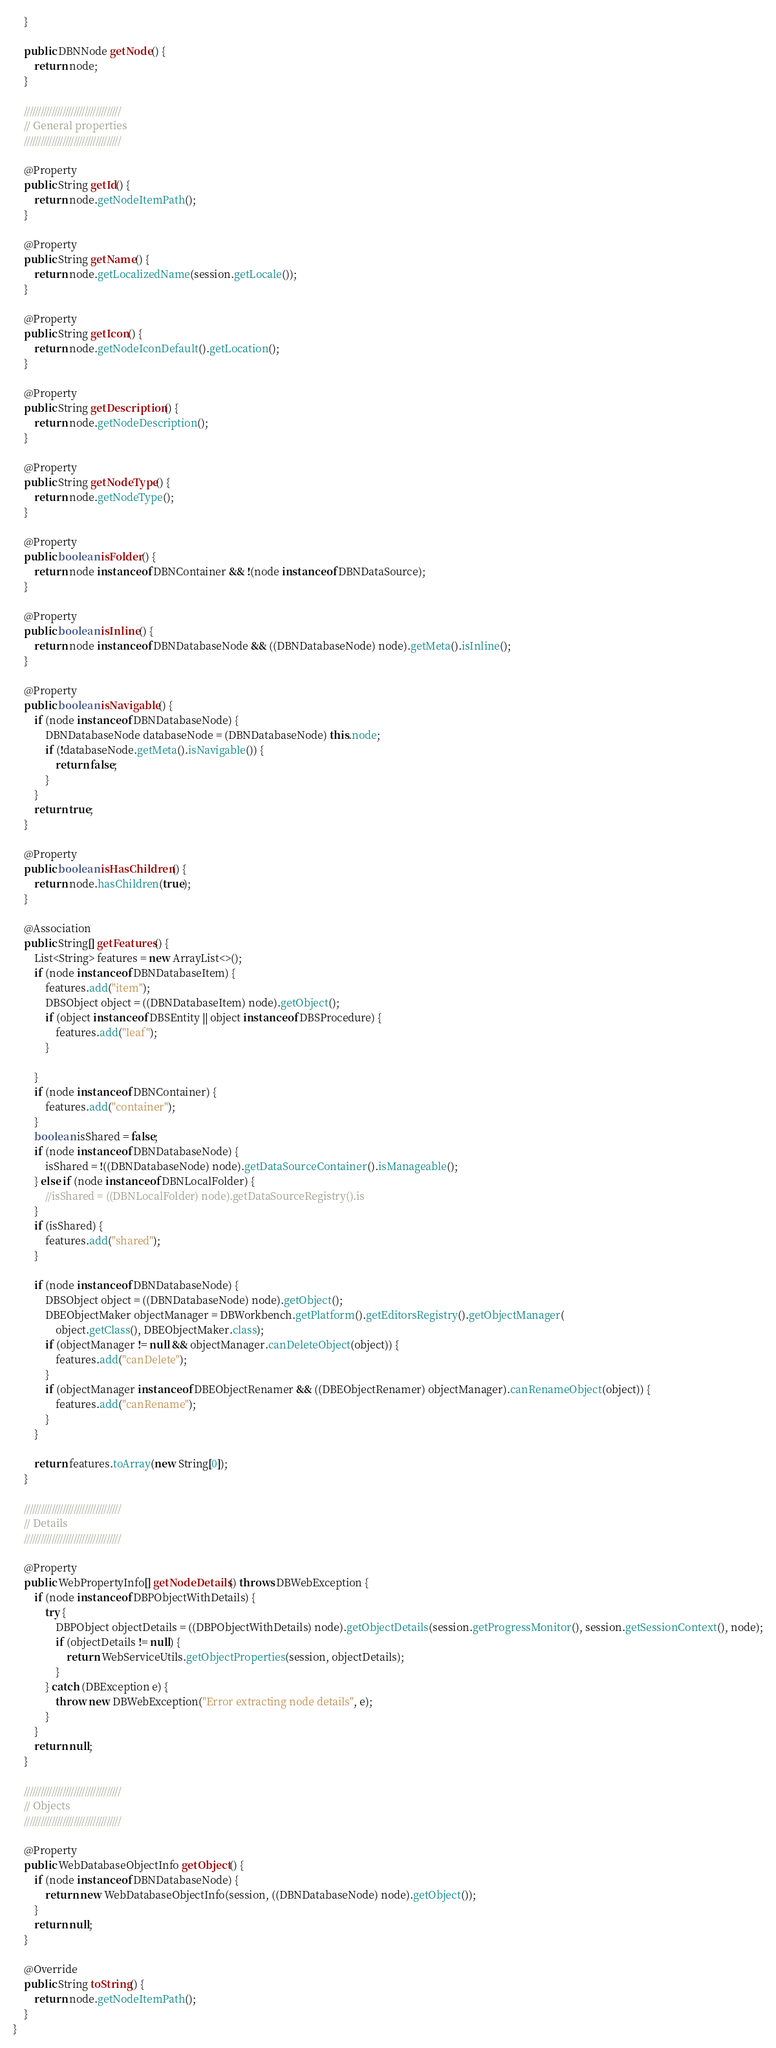Convert code to text. <code><loc_0><loc_0><loc_500><loc_500><_Java_>    }

    public DBNNode getNode() {
        return node;
    }

    ///////////////////////////////////
    // General properties
    ///////////////////////////////////

    @Property
    public String getId() {
        return node.getNodeItemPath();
    }

    @Property
    public String getName() {
        return node.getLocalizedName(session.getLocale());
    }

    @Property
    public String getIcon() {
        return node.getNodeIconDefault().getLocation();
    }

    @Property
    public String getDescription() {
        return node.getNodeDescription();
    }

    @Property
    public String getNodeType() {
        return node.getNodeType();
    }

    @Property
    public boolean isFolder() {
        return node instanceof DBNContainer && !(node instanceof DBNDataSource);
    }

    @Property
    public boolean isInline() {
        return node instanceof DBNDatabaseNode && ((DBNDatabaseNode) node).getMeta().isInline();
    }

    @Property
    public boolean isNavigable() {
        if (node instanceof DBNDatabaseNode) {
            DBNDatabaseNode databaseNode = (DBNDatabaseNode) this.node;
            if (!databaseNode.getMeta().isNavigable()) {
                return false;
            }
        }
        return true;
    }

    @Property
    public boolean isHasChildren() {
        return node.hasChildren(true);
    }

    @Association
    public String[] getFeatures() {
        List<String> features = new ArrayList<>();
        if (node instanceof DBNDatabaseItem) {
            features.add("item");
            DBSObject object = ((DBNDatabaseItem) node).getObject();
            if (object instanceof DBSEntity || object instanceof DBSProcedure) {
                features.add("leaf");
            }

        }
        if (node instanceof DBNContainer) {
            features.add("container");
        }
        boolean isShared = false;
        if (node instanceof DBNDatabaseNode) {
            isShared = !((DBNDatabaseNode) node).getDataSourceContainer().isManageable();
        } else if (node instanceof DBNLocalFolder) {
            //isShared = ((DBNLocalFolder) node).getDataSourceRegistry().is
        }
        if (isShared) {
            features.add("shared");
        }

        if (node instanceof DBNDatabaseNode) {
            DBSObject object = ((DBNDatabaseNode) node).getObject();
            DBEObjectMaker objectManager = DBWorkbench.getPlatform().getEditorsRegistry().getObjectManager(
                object.getClass(), DBEObjectMaker.class);
            if (objectManager != null && objectManager.canDeleteObject(object)) {
                features.add("canDelete");
            }
            if (objectManager instanceof DBEObjectRenamer && ((DBEObjectRenamer) objectManager).canRenameObject(object)) {
                features.add("canRename");
            }
        }

        return features.toArray(new String[0]);
    }

    ///////////////////////////////////
    // Details
    ///////////////////////////////////

    @Property
    public WebPropertyInfo[] getNodeDetails() throws DBWebException {
        if (node instanceof DBPObjectWithDetails) {
            try {
                DBPObject objectDetails = ((DBPObjectWithDetails) node).getObjectDetails(session.getProgressMonitor(), session.getSessionContext(), node);
                if (objectDetails != null) {
                    return WebServiceUtils.getObjectProperties(session, objectDetails);
                }
            } catch (DBException e) {
                throw new DBWebException("Error extracting node details", e);
            }
        }
        return null;
    }

    ///////////////////////////////////
    // Objects
    ///////////////////////////////////

    @Property
    public WebDatabaseObjectInfo getObject() {
        if (node instanceof DBNDatabaseNode) {
            return new WebDatabaseObjectInfo(session, ((DBNDatabaseNode) node).getObject());
        }
        return null;
    }

    @Override
    public String toString() {
        return node.getNodeItemPath();
    }
}
</code> 